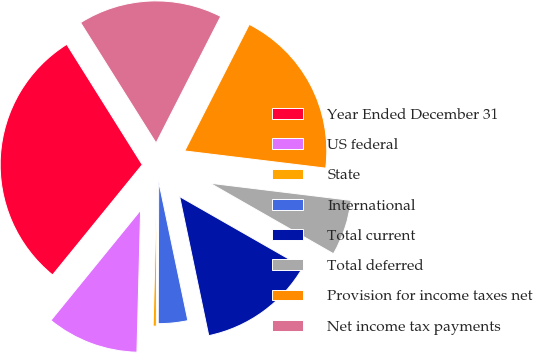Convert chart. <chart><loc_0><loc_0><loc_500><loc_500><pie_chart><fcel>Year Ended December 31<fcel>US federal<fcel>State<fcel>International<fcel>Total current<fcel>Total deferred<fcel>Provision for income taxes net<fcel>Net income tax payments<nl><fcel>30.21%<fcel>10.46%<fcel>0.36%<fcel>3.34%<fcel>13.45%<fcel>6.33%<fcel>19.42%<fcel>16.43%<nl></chart> 